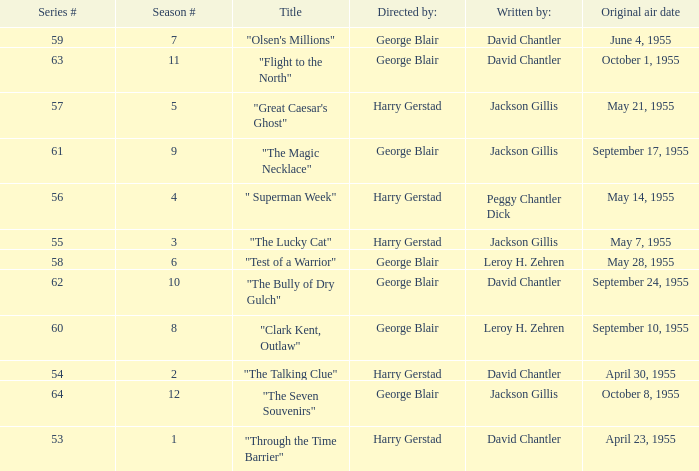When did season 9 originally air? September 17, 1955. 